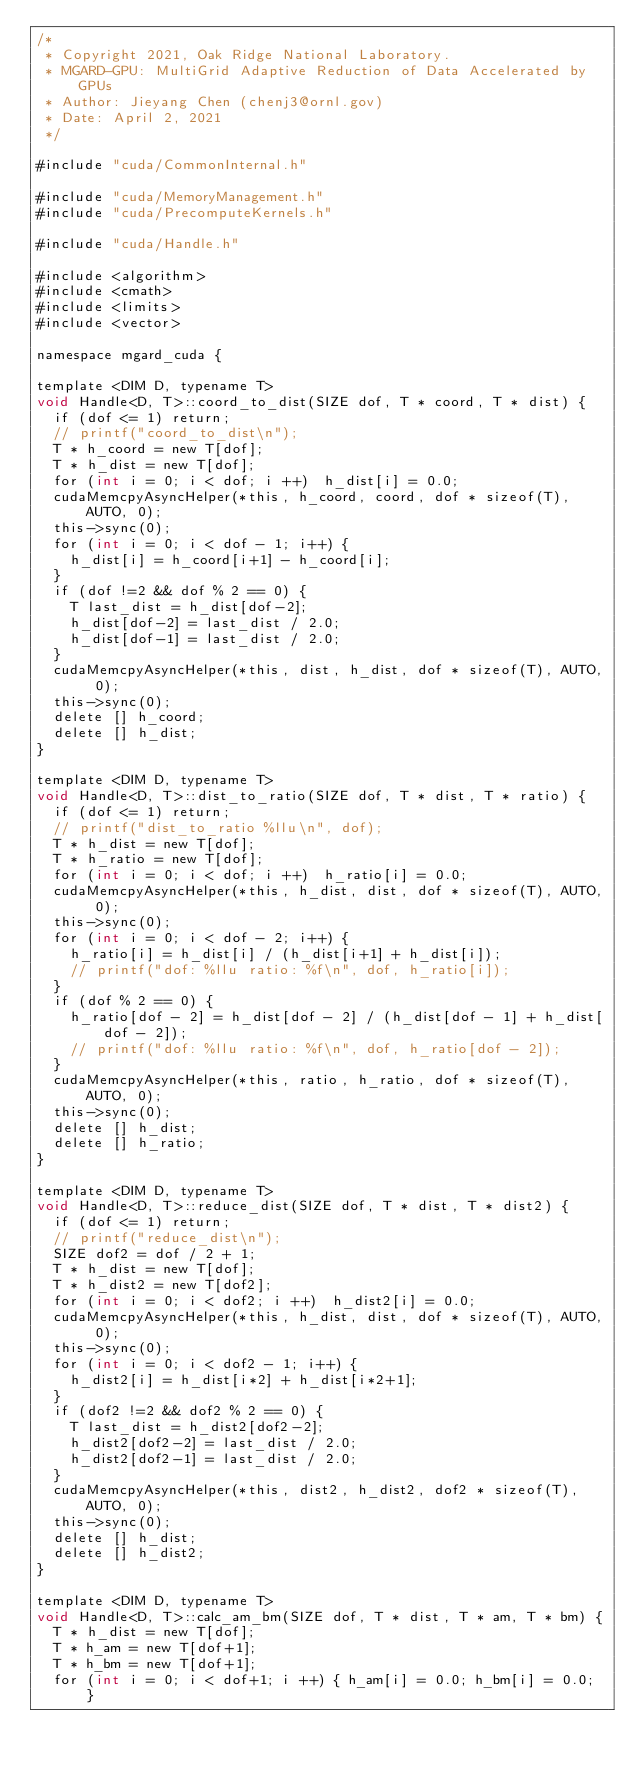Convert code to text. <code><loc_0><loc_0><loc_500><loc_500><_Cuda_>/*
 * Copyright 2021, Oak Ridge National Laboratory.
 * MGARD-GPU: MultiGrid Adaptive Reduction of Data Accelerated by GPUs
 * Author: Jieyang Chen (chenj3@ornl.gov)
 * Date: April 2, 2021
 */

#include "cuda/CommonInternal.h"

#include "cuda/MemoryManagement.h"
#include "cuda/PrecomputeKernels.h"

#include "cuda/Handle.h"

#include <algorithm>
#include <cmath>
#include <limits>
#include <vector>

namespace mgard_cuda {

template <DIM D, typename T>
void Handle<D, T>::coord_to_dist(SIZE dof, T * coord, T * dist) {
  if (dof <= 1) return;
  // printf("coord_to_dist\n");
  T * h_coord = new T[dof];
  T * h_dist = new T[dof];
  for (int i = 0; i < dof; i ++)  h_dist[i] = 0.0;
  cudaMemcpyAsyncHelper(*this, h_coord, coord, dof * sizeof(T), AUTO, 0);
  this->sync(0);
  for (int i = 0; i < dof - 1; i++) {
    h_dist[i] = h_coord[i+1] - h_coord[i];
  }
  if (dof !=2 && dof % 2 == 0) {
    T last_dist = h_dist[dof-2];
    h_dist[dof-2] = last_dist / 2.0;
    h_dist[dof-1] = last_dist / 2.0;
  }
  cudaMemcpyAsyncHelper(*this, dist, h_dist, dof * sizeof(T), AUTO, 0);
  this->sync(0);
  delete [] h_coord;
  delete [] h_dist;
}

template <DIM D, typename T>
void Handle<D, T>::dist_to_ratio(SIZE dof, T * dist, T * ratio) {
  if (dof <= 1) return;
  // printf("dist_to_ratio %llu\n", dof);
  T * h_dist = new T[dof];
  T * h_ratio = new T[dof];
  for (int i = 0; i < dof; i ++)  h_ratio[i] = 0.0;
  cudaMemcpyAsyncHelper(*this, h_dist, dist, dof * sizeof(T), AUTO, 0);
  this->sync(0);
  for (int i = 0; i < dof - 2; i++) {
    h_ratio[i] = h_dist[i] / (h_dist[i+1] + h_dist[i]);
    // printf("dof: %llu ratio: %f\n", dof, h_ratio[i]);
  }
  if (dof % 2 == 0) {
    h_ratio[dof - 2] = h_dist[dof - 2] / (h_dist[dof - 1] + h_dist[dof - 2]);
    // printf("dof: %llu ratio: %f\n", dof, h_ratio[dof - 2]);
  }
  cudaMemcpyAsyncHelper(*this, ratio, h_ratio, dof * sizeof(T), AUTO, 0);
  this->sync(0);
  delete [] h_dist;
  delete [] h_ratio;
}

template <DIM D, typename T>
void Handle<D, T>::reduce_dist(SIZE dof, T * dist, T * dist2) {
  if (dof <= 1) return;
  // printf("reduce_dist\n");
  SIZE dof2 = dof / 2 + 1;
  T * h_dist = new T[dof];
  T * h_dist2 = new T[dof2];
  for (int i = 0; i < dof2; i ++)  h_dist2[i] = 0.0;
  cudaMemcpyAsyncHelper(*this, h_dist, dist, dof * sizeof(T), AUTO, 0);
  this->sync(0);  
  for (int i = 0; i < dof2 - 1; i++) {
    h_dist2[i] = h_dist[i*2] + h_dist[i*2+1]; 
  }
  if (dof2 !=2 && dof2 % 2 == 0) {
    T last_dist = h_dist2[dof2-2];
    h_dist2[dof2-2] = last_dist / 2.0;
    h_dist2[dof2-1] = last_dist / 2.0;
  }
  cudaMemcpyAsyncHelper(*this, dist2, h_dist2, dof2 * sizeof(T), AUTO, 0);
  this->sync(0);
  delete [] h_dist;
  delete [] h_dist2;
}

template <DIM D, typename T>
void Handle<D, T>::calc_am_bm(SIZE dof, T * dist, T * am, T * bm) {
  T * h_dist = new T[dof];
  T * h_am = new T[dof+1];
  T * h_bm = new T[dof+1];
  for (int i = 0; i < dof+1; i ++) { h_am[i] = 0.0; h_bm[i] = 0.0; }</code> 